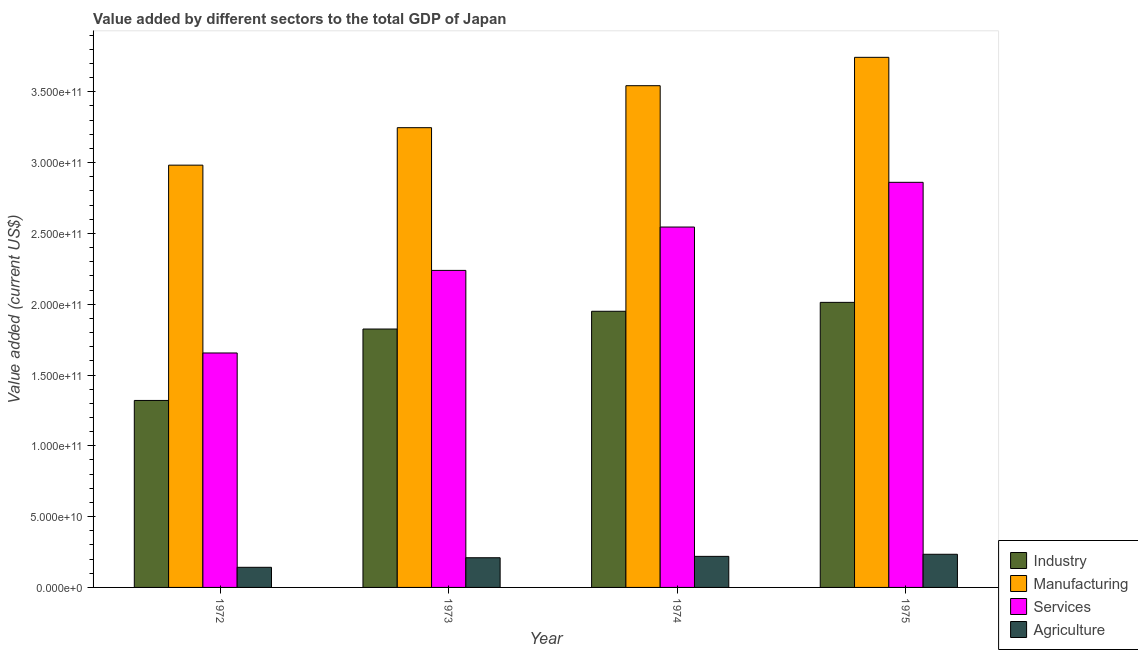Are the number of bars per tick equal to the number of legend labels?
Ensure brevity in your answer.  Yes. Are the number of bars on each tick of the X-axis equal?
Keep it short and to the point. Yes. How many bars are there on the 1st tick from the right?
Your answer should be very brief. 4. What is the label of the 4th group of bars from the left?
Your answer should be very brief. 1975. In how many cases, is the number of bars for a given year not equal to the number of legend labels?
Ensure brevity in your answer.  0. What is the value added by services sector in 1974?
Your response must be concise. 2.55e+11. Across all years, what is the maximum value added by manufacturing sector?
Keep it short and to the point. 3.74e+11. Across all years, what is the minimum value added by agricultural sector?
Give a very brief answer. 1.42e+1. In which year was the value added by services sector maximum?
Your answer should be compact. 1975. In which year was the value added by industrial sector minimum?
Give a very brief answer. 1972. What is the total value added by manufacturing sector in the graph?
Provide a succinct answer. 1.35e+12. What is the difference between the value added by services sector in 1974 and that in 1975?
Offer a terse response. -3.16e+1. What is the difference between the value added by industrial sector in 1974 and the value added by services sector in 1975?
Your answer should be compact. -6.29e+09. What is the average value added by industrial sector per year?
Offer a terse response. 1.78e+11. What is the ratio of the value added by industrial sector in 1973 to that in 1974?
Ensure brevity in your answer.  0.94. Is the difference between the value added by industrial sector in 1974 and 1975 greater than the difference between the value added by agricultural sector in 1974 and 1975?
Your answer should be very brief. No. What is the difference between the highest and the second highest value added by services sector?
Your answer should be very brief. 3.16e+1. What is the difference between the highest and the lowest value added by agricultural sector?
Your response must be concise. 9.19e+09. Is the sum of the value added by agricultural sector in 1972 and 1974 greater than the maximum value added by services sector across all years?
Make the answer very short. Yes. What does the 4th bar from the left in 1975 represents?
Your answer should be compact. Agriculture. What does the 4th bar from the right in 1973 represents?
Provide a succinct answer. Industry. Is it the case that in every year, the sum of the value added by industrial sector and value added by manufacturing sector is greater than the value added by services sector?
Provide a short and direct response. Yes. How many bars are there?
Your answer should be compact. 16. Are the values on the major ticks of Y-axis written in scientific E-notation?
Provide a succinct answer. Yes. Does the graph contain grids?
Offer a very short reply. No. How are the legend labels stacked?
Offer a very short reply. Vertical. What is the title of the graph?
Keep it short and to the point. Value added by different sectors to the total GDP of Japan. Does "Denmark" appear as one of the legend labels in the graph?
Make the answer very short. No. What is the label or title of the Y-axis?
Offer a very short reply. Value added (current US$). What is the Value added (current US$) in Industry in 1972?
Offer a very short reply. 1.32e+11. What is the Value added (current US$) of Manufacturing in 1972?
Your answer should be very brief. 2.98e+11. What is the Value added (current US$) of Services in 1972?
Offer a terse response. 1.66e+11. What is the Value added (current US$) in Agriculture in 1972?
Ensure brevity in your answer.  1.42e+1. What is the Value added (current US$) in Industry in 1973?
Provide a succinct answer. 1.82e+11. What is the Value added (current US$) in Manufacturing in 1973?
Make the answer very short. 3.25e+11. What is the Value added (current US$) of Services in 1973?
Give a very brief answer. 2.24e+11. What is the Value added (current US$) of Agriculture in 1973?
Your answer should be compact. 2.10e+1. What is the Value added (current US$) in Industry in 1974?
Give a very brief answer. 1.95e+11. What is the Value added (current US$) in Manufacturing in 1974?
Provide a succinct answer. 3.54e+11. What is the Value added (current US$) of Services in 1974?
Provide a succinct answer. 2.55e+11. What is the Value added (current US$) of Agriculture in 1974?
Provide a succinct answer. 2.19e+1. What is the Value added (current US$) in Industry in 1975?
Provide a short and direct response. 2.01e+11. What is the Value added (current US$) of Manufacturing in 1975?
Ensure brevity in your answer.  3.74e+11. What is the Value added (current US$) in Services in 1975?
Provide a succinct answer. 2.86e+11. What is the Value added (current US$) of Agriculture in 1975?
Offer a very short reply. 2.34e+1. Across all years, what is the maximum Value added (current US$) in Industry?
Ensure brevity in your answer.  2.01e+11. Across all years, what is the maximum Value added (current US$) of Manufacturing?
Your response must be concise. 3.74e+11. Across all years, what is the maximum Value added (current US$) of Services?
Your answer should be compact. 2.86e+11. Across all years, what is the maximum Value added (current US$) of Agriculture?
Keep it short and to the point. 2.34e+1. Across all years, what is the minimum Value added (current US$) in Industry?
Provide a short and direct response. 1.32e+11. Across all years, what is the minimum Value added (current US$) in Manufacturing?
Your answer should be very brief. 2.98e+11. Across all years, what is the minimum Value added (current US$) of Services?
Offer a terse response. 1.66e+11. Across all years, what is the minimum Value added (current US$) in Agriculture?
Your answer should be compact. 1.42e+1. What is the total Value added (current US$) of Industry in the graph?
Offer a terse response. 7.11e+11. What is the total Value added (current US$) of Manufacturing in the graph?
Provide a short and direct response. 1.35e+12. What is the total Value added (current US$) in Services in the graph?
Offer a terse response. 9.30e+11. What is the total Value added (current US$) in Agriculture in the graph?
Provide a short and direct response. 8.05e+1. What is the difference between the Value added (current US$) of Industry in 1972 and that in 1973?
Provide a short and direct response. -5.04e+1. What is the difference between the Value added (current US$) of Manufacturing in 1972 and that in 1973?
Keep it short and to the point. -2.65e+1. What is the difference between the Value added (current US$) of Services in 1972 and that in 1973?
Provide a short and direct response. -5.83e+1. What is the difference between the Value added (current US$) in Agriculture in 1972 and that in 1973?
Offer a very short reply. -6.75e+09. What is the difference between the Value added (current US$) in Industry in 1972 and that in 1974?
Offer a terse response. -6.30e+1. What is the difference between the Value added (current US$) of Manufacturing in 1972 and that in 1974?
Your response must be concise. -5.61e+1. What is the difference between the Value added (current US$) of Services in 1972 and that in 1974?
Offer a very short reply. -8.89e+1. What is the difference between the Value added (current US$) of Agriculture in 1972 and that in 1974?
Provide a succinct answer. -7.72e+09. What is the difference between the Value added (current US$) in Industry in 1972 and that in 1975?
Provide a succinct answer. -6.93e+1. What is the difference between the Value added (current US$) of Manufacturing in 1972 and that in 1975?
Your answer should be very brief. -7.61e+1. What is the difference between the Value added (current US$) of Services in 1972 and that in 1975?
Give a very brief answer. -1.21e+11. What is the difference between the Value added (current US$) in Agriculture in 1972 and that in 1975?
Your response must be concise. -9.19e+09. What is the difference between the Value added (current US$) in Industry in 1973 and that in 1974?
Offer a very short reply. -1.25e+1. What is the difference between the Value added (current US$) of Manufacturing in 1973 and that in 1974?
Your answer should be very brief. -2.96e+1. What is the difference between the Value added (current US$) in Services in 1973 and that in 1974?
Your response must be concise. -3.06e+1. What is the difference between the Value added (current US$) of Agriculture in 1973 and that in 1974?
Your answer should be compact. -9.64e+08. What is the difference between the Value added (current US$) in Industry in 1973 and that in 1975?
Provide a short and direct response. -1.88e+1. What is the difference between the Value added (current US$) of Manufacturing in 1973 and that in 1975?
Provide a succinct answer. -4.97e+1. What is the difference between the Value added (current US$) of Services in 1973 and that in 1975?
Offer a very short reply. -6.22e+1. What is the difference between the Value added (current US$) of Agriculture in 1973 and that in 1975?
Give a very brief answer. -2.44e+09. What is the difference between the Value added (current US$) of Industry in 1974 and that in 1975?
Give a very brief answer. -6.29e+09. What is the difference between the Value added (current US$) of Manufacturing in 1974 and that in 1975?
Make the answer very short. -2.00e+1. What is the difference between the Value added (current US$) of Services in 1974 and that in 1975?
Provide a short and direct response. -3.16e+1. What is the difference between the Value added (current US$) of Agriculture in 1974 and that in 1975?
Keep it short and to the point. -1.48e+09. What is the difference between the Value added (current US$) of Industry in 1972 and the Value added (current US$) of Manufacturing in 1973?
Keep it short and to the point. -1.93e+11. What is the difference between the Value added (current US$) in Industry in 1972 and the Value added (current US$) in Services in 1973?
Your answer should be compact. -9.18e+1. What is the difference between the Value added (current US$) in Industry in 1972 and the Value added (current US$) in Agriculture in 1973?
Your answer should be very brief. 1.11e+11. What is the difference between the Value added (current US$) of Manufacturing in 1972 and the Value added (current US$) of Services in 1973?
Ensure brevity in your answer.  7.43e+1. What is the difference between the Value added (current US$) of Manufacturing in 1972 and the Value added (current US$) of Agriculture in 1973?
Keep it short and to the point. 2.77e+11. What is the difference between the Value added (current US$) of Services in 1972 and the Value added (current US$) of Agriculture in 1973?
Keep it short and to the point. 1.45e+11. What is the difference between the Value added (current US$) in Industry in 1972 and the Value added (current US$) in Manufacturing in 1974?
Ensure brevity in your answer.  -2.22e+11. What is the difference between the Value added (current US$) in Industry in 1972 and the Value added (current US$) in Services in 1974?
Give a very brief answer. -1.22e+11. What is the difference between the Value added (current US$) in Industry in 1972 and the Value added (current US$) in Agriculture in 1974?
Offer a very short reply. 1.10e+11. What is the difference between the Value added (current US$) in Manufacturing in 1972 and the Value added (current US$) in Services in 1974?
Provide a short and direct response. 4.37e+1. What is the difference between the Value added (current US$) in Manufacturing in 1972 and the Value added (current US$) in Agriculture in 1974?
Provide a succinct answer. 2.76e+11. What is the difference between the Value added (current US$) in Services in 1972 and the Value added (current US$) in Agriculture in 1974?
Give a very brief answer. 1.44e+11. What is the difference between the Value added (current US$) of Industry in 1972 and the Value added (current US$) of Manufacturing in 1975?
Your answer should be very brief. -2.42e+11. What is the difference between the Value added (current US$) of Industry in 1972 and the Value added (current US$) of Services in 1975?
Keep it short and to the point. -1.54e+11. What is the difference between the Value added (current US$) in Industry in 1972 and the Value added (current US$) in Agriculture in 1975?
Offer a very short reply. 1.09e+11. What is the difference between the Value added (current US$) in Manufacturing in 1972 and the Value added (current US$) in Services in 1975?
Offer a very short reply. 1.21e+1. What is the difference between the Value added (current US$) in Manufacturing in 1972 and the Value added (current US$) in Agriculture in 1975?
Make the answer very short. 2.75e+11. What is the difference between the Value added (current US$) in Services in 1972 and the Value added (current US$) in Agriculture in 1975?
Your answer should be very brief. 1.42e+11. What is the difference between the Value added (current US$) of Industry in 1973 and the Value added (current US$) of Manufacturing in 1974?
Ensure brevity in your answer.  -1.72e+11. What is the difference between the Value added (current US$) of Industry in 1973 and the Value added (current US$) of Services in 1974?
Keep it short and to the point. -7.20e+1. What is the difference between the Value added (current US$) in Industry in 1973 and the Value added (current US$) in Agriculture in 1974?
Offer a very short reply. 1.61e+11. What is the difference between the Value added (current US$) of Manufacturing in 1973 and the Value added (current US$) of Services in 1974?
Give a very brief answer. 7.02e+1. What is the difference between the Value added (current US$) of Manufacturing in 1973 and the Value added (current US$) of Agriculture in 1974?
Give a very brief answer. 3.03e+11. What is the difference between the Value added (current US$) in Services in 1973 and the Value added (current US$) in Agriculture in 1974?
Make the answer very short. 2.02e+11. What is the difference between the Value added (current US$) in Industry in 1973 and the Value added (current US$) in Manufacturing in 1975?
Provide a short and direct response. -1.92e+11. What is the difference between the Value added (current US$) in Industry in 1973 and the Value added (current US$) in Services in 1975?
Ensure brevity in your answer.  -1.04e+11. What is the difference between the Value added (current US$) in Industry in 1973 and the Value added (current US$) in Agriculture in 1975?
Your answer should be compact. 1.59e+11. What is the difference between the Value added (current US$) in Manufacturing in 1973 and the Value added (current US$) in Services in 1975?
Offer a terse response. 3.86e+1. What is the difference between the Value added (current US$) of Manufacturing in 1973 and the Value added (current US$) of Agriculture in 1975?
Provide a short and direct response. 3.01e+11. What is the difference between the Value added (current US$) in Services in 1973 and the Value added (current US$) in Agriculture in 1975?
Offer a terse response. 2.00e+11. What is the difference between the Value added (current US$) in Industry in 1974 and the Value added (current US$) in Manufacturing in 1975?
Offer a very short reply. -1.79e+11. What is the difference between the Value added (current US$) in Industry in 1974 and the Value added (current US$) in Services in 1975?
Make the answer very short. -9.11e+1. What is the difference between the Value added (current US$) of Industry in 1974 and the Value added (current US$) of Agriculture in 1975?
Offer a very short reply. 1.72e+11. What is the difference between the Value added (current US$) in Manufacturing in 1974 and the Value added (current US$) in Services in 1975?
Your response must be concise. 6.82e+1. What is the difference between the Value added (current US$) of Manufacturing in 1974 and the Value added (current US$) of Agriculture in 1975?
Offer a very short reply. 3.31e+11. What is the difference between the Value added (current US$) in Services in 1974 and the Value added (current US$) in Agriculture in 1975?
Your answer should be compact. 2.31e+11. What is the average Value added (current US$) in Industry per year?
Your response must be concise. 1.78e+11. What is the average Value added (current US$) in Manufacturing per year?
Ensure brevity in your answer.  3.38e+11. What is the average Value added (current US$) in Services per year?
Ensure brevity in your answer.  2.33e+11. What is the average Value added (current US$) in Agriculture per year?
Keep it short and to the point. 2.01e+1. In the year 1972, what is the difference between the Value added (current US$) in Industry and Value added (current US$) in Manufacturing?
Give a very brief answer. -1.66e+11. In the year 1972, what is the difference between the Value added (current US$) of Industry and Value added (current US$) of Services?
Give a very brief answer. -3.35e+1. In the year 1972, what is the difference between the Value added (current US$) in Industry and Value added (current US$) in Agriculture?
Keep it short and to the point. 1.18e+11. In the year 1972, what is the difference between the Value added (current US$) in Manufacturing and Value added (current US$) in Services?
Offer a very short reply. 1.33e+11. In the year 1972, what is the difference between the Value added (current US$) of Manufacturing and Value added (current US$) of Agriculture?
Keep it short and to the point. 2.84e+11. In the year 1972, what is the difference between the Value added (current US$) of Services and Value added (current US$) of Agriculture?
Offer a very short reply. 1.51e+11. In the year 1973, what is the difference between the Value added (current US$) of Industry and Value added (current US$) of Manufacturing?
Give a very brief answer. -1.42e+11. In the year 1973, what is the difference between the Value added (current US$) of Industry and Value added (current US$) of Services?
Offer a terse response. -4.14e+1. In the year 1973, what is the difference between the Value added (current US$) in Industry and Value added (current US$) in Agriculture?
Ensure brevity in your answer.  1.62e+11. In the year 1973, what is the difference between the Value added (current US$) of Manufacturing and Value added (current US$) of Services?
Your answer should be very brief. 1.01e+11. In the year 1973, what is the difference between the Value added (current US$) in Manufacturing and Value added (current US$) in Agriculture?
Make the answer very short. 3.04e+11. In the year 1973, what is the difference between the Value added (current US$) in Services and Value added (current US$) in Agriculture?
Your answer should be very brief. 2.03e+11. In the year 1974, what is the difference between the Value added (current US$) of Industry and Value added (current US$) of Manufacturing?
Make the answer very short. -1.59e+11. In the year 1974, what is the difference between the Value added (current US$) of Industry and Value added (current US$) of Services?
Offer a very short reply. -5.95e+1. In the year 1974, what is the difference between the Value added (current US$) in Industry and Value added (current US$) in Agriculture?
Offer a terse response. 1.73e+11. In the year 1974, what is the difference between the Value added (current US$) in Manufacturing and Value added (current US$) in Services?
Give a very brief answer. 9.98e+1. In the year 1974, what is the difference between the Value added (current US$) of Manufacturing and Value added (current US$) of Agriculture?
Give a very brief answer. 3.32e+11. In the year 1974, what is the difference between the Value added (current US$) of Services and Value added (current US$) of Agriculture?
Your answer should be compact. 2.33e+11. In the year 1975, what is the difference between the Value added (current US$) of Industry and Value added (current US$) of Manufacturing?
Make the answer very short. -1.73e+11. In the year 1975, what is the difference between the Value added (current US$) of Industry and Value added (current US$) of Services?
Make the answer very short. -8.48e+1. In the year 1975, what is the difference between the Value added (current US$) in Industry and Value added (current US$) in Agriculture?
Your answer should be very brief. 1.78e+11. In the year 1975, what is the difference between the Value added (current US$) in Manufacturing and Value added (current US$) in Services?
Your response must be concise. 8.83e+1. In the year 1975, what is the difference between the Value added (current US$) of Manufacturing and Value added (current US$) of Agriculture?
Your response must be concise. 3.51e+11. In the year 1975, what is the difference between the Value added (current US$) of Services and Value added (current US$) of Agriculture?
Ensure brevity in your answer.  2.63e+11. What is the ratio of the Value added (current US$) of Industry in 1972 to that in 1973?
Make the answer very short. 0.72. What is the ratio of the Value added (current US$) in Manufacturing in 1972 to that in 1973?
Keep it short and to the point. 0.92. What is the ratio of the Value added (current US$) in Services in 1972 to that in 1973?
Offer a very short reply. 0.74. What is the ratio of the Value added (current US$) in Agriculture in 1972 to that in 1973?
Provide a short and direct response. 0.68. What is the ratio of the Value added (current US$) of Industry in 1972 to that in 1974?
Give a very brief answer. 0.68. What is the ratio of the Value added (current US$) in Manufacturing in 1972 to that in 1974?
Make the answer very short. 0.84. What is the ratio of the Value added (current US$) in Services in 1972 to that in 1974?
Provide a short and direct response. 0.65. What is the ratio of the Value added (current US$) of Agriculture in 1972 to that in 1974?
Your answer should be compact. 0.65. What is the ratio of the Value added (current US$) in Industry in 1972 to that in 1975?
Provide a short and direct response. 0.66. What is the ratio of the Value added (current US$) of Manufacturing in 1972 to that in 1975?
Make the answer very short. 0.8. What is the ratio of the Value added (current US$) in Services in 1972 to that in 1975?
Your response must be concise. 0.58. What is the ratio of the Value added (current US$) of Agriculture in 1972 to that in 1975?
Make the answer very short. 0.61. What is the ratio of the Value added (current US$) in Industry in 1973 to that in 1974?
Your response must be concise. 0.94. What is the ratio of the Value added (current US$) in Manufacturing in 1973 to that in 1974?
Offer a terse response. 0.92. What is the ratio of the Value added (current US$) in Services in 1973 to that in 1974?
Your response must be concise. 0.88. What is the ratio of the Value added (current US$) of Agriculture in 1973 to that in 1974?
Your answer should be compact. 0.96. What is the ratio of the Value added (current US$) of Industry in 1973 to that in 1975?
Provide a succinct answer. 0.91. What is the ratio of the Value added (current US$) in Manufacturing in 1973 to that in 1975?
Keep it short and to the point. 0.87. What is the ratio of the Value added (current US$) of Services in 1973 to that in 1975?
Provide a succinct answer. 0.78. What is the ratio of the Value added (current US$) of Agriculture in 1973 to that in 1975?
Give a very brief answer. 0.9. What is the ratio of the Value added (current US$) of Industry in 1974 to that in 1975?
Your answer should be very brief. 0.97. What is the ratio of the Value added (current US$) in Manufacturing in 1974 to that in 1975?
Make the answer very short. 0.95. What is the ratio of the Value added (current US$) of Services in 1974 to that in 1975?
Your response must be concise. 0.89. What is the ratio of the Value added (current US$) in Agriculture in 1974 to that in 1975?
Give a very brief answer. 0.94. What is the difference between the highest and the second highest Value added (current US$) in Industry?
Make the answer very short. 6.29e+09. What is the difference between the highest and the second highest Value added (current US$) of Manufacturing?
Provide a succinct answer. 2.00e+1. What is the difference between the highest and the second highest Value added (current US$) of Services?
Your answer should be very brief. 3.16e+1. What is the difference between the highest and the second highest Value added (current US$) of Agriculture?
Make the answer very short. 1.48e+09. What is the difference between the highest and the lowest Value added (current US$) of Industry?
Your answer should be very brief. 6.93e+1. What is the difference between the highest and the lowest Value added (current US$) of Manufacturing?
Your answer should be very brief. 7.61e+1. What is the difference between the highest and the lowest Value added (current US$) in Services?
Make the answer very short. 1.21e+11. What is the difference between the highest and the lowest Value added (current US$) of Agriculture?
Keep it short and to the point. 9.19e+09. 